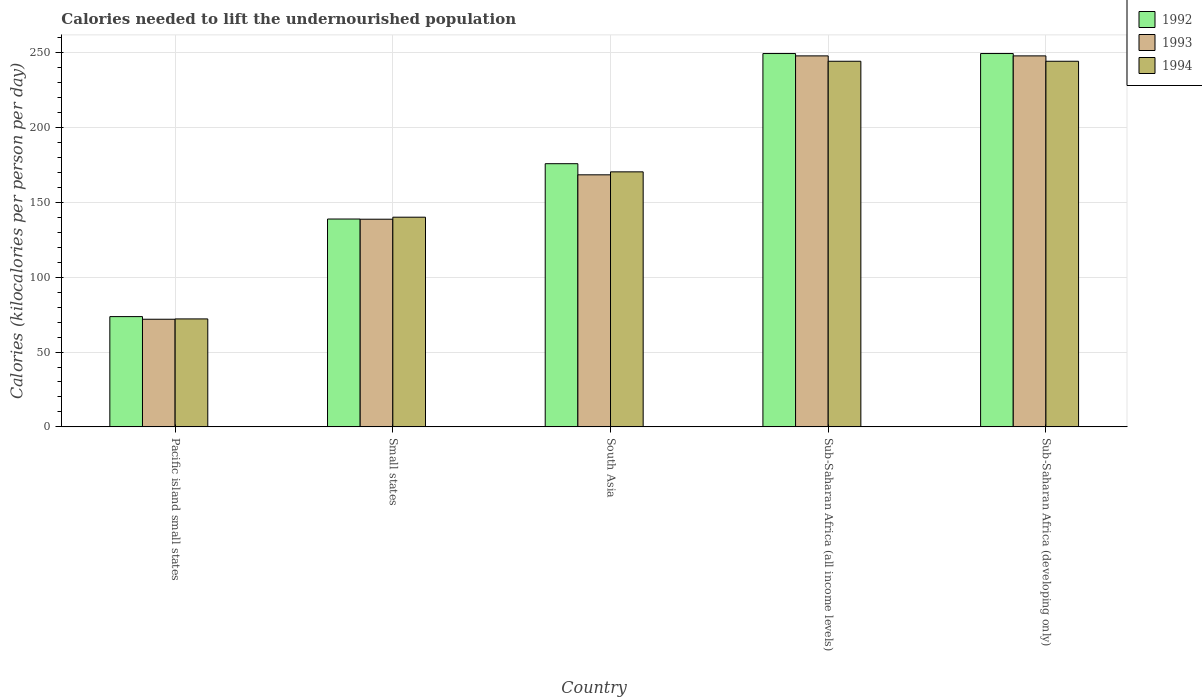How many groups of bars are there?
Make the answer very short. 5. Are the number of bars per tick equal to the number of legend labels?
Your answer should be very brief. Yes. How many bars are there on the 5th tick from the left?
Make the answer very short. 3. What is the label of the 1st group of bars from the left?
Your answer should be very brief. Pacific island small states. What is the total calories needed to lift the undernourished population in 1994 in Small states?
Keep it short and to the point. 140.1. Across all countries, what is the maximum total calories needed to lift the undernourished population in 1993?
Provide a short and direct response. 247.89. Across all countries, what is the minimum total calories needed to lift the undernourished population in 1992?
Give a very brief answer. 73.68. In which country was the total calories needed to lift the undernourished population in 1993 maximum?
Your response must be concise. Sub-Saharan Africa (all income levels). In which country was the total calories needed to lift the undernourished population in 1992 minimum?
Give a very brief answer. Pacific island small states. What is the total total calories needed to lift the undernourished population in 1992 in the graph?
Ensure brevity in your answer.  887.31. What is the difference between the total calories needed to lift the undernourished population in 1993 in Pacific island small states and that in Sub-Saharan Africa (all income levels)?
Offer a very short reply. -175.97. What is the difference between the total calories needed to lift the undernourished population in 1992 in Sub-Saharan Africa (developing only) and the total calories needed to lift the undernourished population in 1994 in Pacific island small states?
Make the answer very short. 177.32. What is the average total calories needed to lift the undernourished population in 1994 per country?
Your response must be concise. 174.25. What is the difference between the total calories needed to lift the undernourished population of/in 1992 and total calories needed to lift the undernourished population of/in 1994 in Small states?
Keep it short and to the point. -1.22. In how many countries, is the total calories needed to lift the undernourished population in 1992 greater than 250 kilocalories?
Provide a succinct answer. 0. What is the ratio of the total calories needed to lift the undernourished population in 1994 in Pacific island small states to that in Small states?
Your answer should be compact. 0.51. Is the total calories needed to lift the undernourished population in 1992 in Pacific island small states less than that in Sub-Saharan Africa (all income levels)?
Keep it short and to the point. Yes. What is the difference between the highest and the second highest total calories needed to lift the undernourished population in 1992?
Your answer should be very brief. 73.61. What is the difference between the highest and the lowest total calories needed to lift the undernourished population in 1992?
Your answer should be compact. 175.77. What does the 2nd bar from the left in Small states represents?
Your answer should be very brief. 1993. Is it the case that in every country, the sum of the total calories needed to lift the undernourished population in 1994 and total calories needed to lift the undernourished population in 1992 is greater than the total calories needed to lift the undernourished population in 1993?
Provide a succinct answer. Yes. How many bars are there?
Your answer should be compact. 15. Are all the bars in the graph horizontal?
Give a very brief answer. No. What is the difference between two consecutive major ticks on the Y-axis?
Provide a succinct answer. 50. Does the graph contain grids?
Your response must be concise. Yes. Where does the legend appear in the graph?
Ensure brevity in your answer.  Top right. How many legend labels are there?
Provide a short and direct response. 3. What is the title of the graph?
Your answer should be compact. Calories needed to lift the undernourished population. Does "1995" appear as one of the legend labels in the graph?
Provide a short and direct response. No. What is the label or title of the Y-axis?
Provide a succinct answer. Calories (kilocalories per person per day). What is the Calories (kilocalories per person per day) in 1992 in Pacific island small states?
Your response must be concise. 73.68. What is the Calories (kilocalories per person per day) in 1993 in Pacific island small states?
Your response must be concise. 71.92. What is the Calories (kilocalories per person per day) in 1994 in Pacific island small states?
Keep it short and to the point. 72.13. What is the Calories (kilocalories per person per day) in 1992 in Small states?
Provide a short and direct response. 138.88. What is the Calories (kilocalories per person per day) of 1993 in Small states?
Provide a succinct answer. 138.76. What is the Calories (kilocalories per person per day) in 1994 in Small states?
Keep it short and to the point. 140.1. What is the Calories (kilocalories per person per day) in 1992 in South Asia?
Offer a very short reply. 175.85. What is the Calories (kilocalories per person per day) of 1993 in South Asia?
Give a very brief answer. 168.41. What is the Calories (kilocalories per person per day) of 1994 in South Asia?
Provide a succinct answer. 170.4. What is the Calories (kilocalories per person per day) in 1992 in Sub-Saharan Africa (all income levels)?
Offer a very short reply. 249.45. What is the Calories (kilocalories per person per day) in 1993 in Sub-Saharan Africa (all income levels)?
Your answer should be compact. 247.89. What is the Calories (kilocalories per person per day) in 1994 in Sub-Saharan Africa (all income levels)?
Offer a terse response. 244.29. What is the Calories (kilocalories per person per day) in 1992 in Sub-Saharan Africa (developing only)?
Your answer should be very brief. 249.45. What is the Calories (kilocalories per person per day) of 1993 in Sub-Saharan Africa (developing only)?
Provide a short and direct response. 247.89. What is the Calories (kilocalories per person per day) in 1994 in Sub-Saharan Africa (developing only)?
Offer a very short reply. 244.29. Across all countries, what is the maximum Calories (kilocalories per person per day) of 1992?
Your answer should be very brief. 249.45. Across all countries, what is the maximum Calories (kilocalories per person per day) of 1993?
Provide a short and direct response. 247.89. Across all countries, what is the maximum Calories (kilocalories per person per day) in 1994?
Your answer should be very brief. 244.29. Across all countries, what is the minimum Calories (kilocalories per person per day) in 1992?
Your answer should be very brief. 73.68. Across all countries, what is the minimum Calories (kilocalories per person per day) in 1993?
Your answer should be compact. 71.92. Across all countries, what is the minimum Calories (kilocalories per person per day) in 1994?
Your answer should be compact. 72.13. What is the total Calories (kilocalories per person per day) of 1992 in the graph?
Your answer should be very brief. 887.31. What is the total Calories (kilocalories per person per day) of 1993 in the graph?
Your response must be concise. 874.86. What is the total Calories (kilocalories per person per day) of 1994 in the graph?
Offer a very short reply. 871.23. What is the difference between the Calories (kilocalories per person per day) in 1992 in Pacific island small states and that in Small states?
Provide a succinct answer. -65.2. What is the difference between the Calories (kilocalories per person per day) of 1993 in Pacific island small states and that in Small states?
Keep it short and to the point. -66.84. What is the difference between the Calories (kilocalories per person per day) of 1994 in Pacific island small states and that in Small states?
Your answer should be compact. -67.97. What is the difference between the Calories (kilocalories per person per day) of 1992 in Pacific island small states and that in South Asia?
Your response must be concise. -102.16. What is the difference between the Calories (kilocalories per person per day) of 1993 in Pacific island small states and that in South Asia?
Your answer should be compact. -96.49. What is the difference between the Calories (kilocalories per person per day) of 1994 in Pacific island small states and that in South Asia?
Keep it short and to the point. -98.27. What is the difference between the Calories (kilocalories per person per day) of 1992 in Pacific island small states and that in Sub-Saharan Africa (all income levels)?
Offer a terse response. -175.77. What is the difference between the Calories (kilocalories per person per day) in 1993 in Pacific island small states and that in Sub-Saharan Africa (all income levels)?
Ensure brevity in your answer.  -175.97. What is the difference between the Calories (kilocalories per person per day) in 1994 in Pacific island small states and that in Sub-Saharan Africa (all income levels)?
Keep it short and to the point. -172.16. What is the difference between the Calories (kilocalories per person per day) in 1992 in Pacific island small states and that in Sub-Saharan Africa (developing only)?
Offer a terse response. -175.77. What is the difference between the Calories (kilocalories per person per day) of 1993 in Pacific island small states and that in Sub-Saharan Africa (developing only)?
Keep it short and to the point. -175.97. What is the difference between the Calories (kilocalories per person per day) in 1994 in Pacific island small states and that in Sub-Saharan Africa (developing only)?
Your answer should be very brief. -172.16. What is the difference between the Calories (kilocalories per person per day) in 1992 in Small states and that in South Asia?
Make the answer very short. -36.96. What is the difference between the Calories (kilocalories per person per day) in 1993 in Small states and that in South Asia?
Ensure brevity in your answer.  -29.65. What is the difference between the Calories (kilocalories per person per day) in 1994 in Small states and that in South Asia?
Ensure brevity in your answer.  -30.3. What is the difference between the Calories (kilocalories per person per day) in 1992 in Small states and that in Sub-Saharan Africa (all income levels)?
Provide a short and direct response. -110.57. What is the difference between the Calories (kilocalories per person per day) of 1993 in Small states and that in Sub-Saharan Africa (all income levels)?
Give a very brief answer. -109.13. What is the difference between the Calories (kilocalories per person per day) in 1994 in Small states and that in Sub-Saharan Africa (all income levels)?
Your answer should be very brief. -104.19. What is the difference between the Calories (kilocalories per person per day) in 1992 in Small states and that in Sub-Saharan Africa (developing only)?
Offer a terse response. -110.57. What is the difference between the Calories (kilocalories per person per day) of 1993 in Small states and that in Sub-Saharan Africa (developing only)?
Your response must be concise. -109.13. What is the difference between the Calories (kilocalories per person per day) in 1994 in Small states and that in Sub-Saharan Africa (developing only)?
Your answer should be very brief. -104.19. What is the difference between the Calories (kilocalories per person per day) in 1992 in South Asia and that in Sub-Saharan Africa (all income levels)?
Keep it short and to the point. -73.61. What is the difference between the Calories (kilocalories per person per day) in 1993 in South Asia and that in Sub-Saharan Africa (all income levels)?
Provide a short and direct response. -79.48. What is the difference between the Calories (kilocalories per person per day) of 1994 in South Asia and that in Sub-Saharan Africa (all income levels)?
Give a very brief answer. -73.89. What is the difference between the Calories (kilocalories per person per day) in 1992 in South Asia and that in Sub-Saharan Africa (developing only)?
Your answer should be very brief. -73.61. What is the difference between the Calories (kilocalories per person per day) in 1993 in South Asia and that in Sub-Saharan Africa (developing only)?
Provide a short and direct response. -79.48. What is the difference between the Calories (kilocalories per person per day) of 1994 in South Asia and that in Sub-Saharan Africa (developing only)?
Your answer should be compact. -73.89. What is the difference between the Calories (kilocalories per person per day) of 1992 in Sub-Saharan Africa (all income levels) and that in Sub-Saharan Africa (developing only)?
Make the answer very short. 0. What is the difference between the Calories (kilocalories per person per day) in 1994 in Sub-Saharan Africa (all income levels) and that in Sub-Saharan Africa (developing only)?
Your answer should be very brief. 0. What is the difference between the Calories (kilocalories per person per day) of 1992 in Pacific island small states and the Calories (kilocalories per person per day) of 1993 in Small states?
Your response must be concise. -65.07. What is the difference between the Calories (kilocalories per person per day) of 1992 in Pacific island small states and the Calories (kilocalories per person per day) of 1994 in Small states?
Give a very brief answer. -66.42. What is the difference between the Calories (kilocalories per person per day) of 1993 in Pacific island small states and the Calories (kilocalories per person per day) of 1994 in Small states?
Offer a terse response. -68.18. What is the difference between the Calories (kilocalories per person per day) of 1992 in Pacific island small states and the Calories (kilocalories per person per day) of 1993 in South Asia?
Provide a succinct answer. -94.73. What is the difference between the Calories (kilocalories per person per day) in 1992 in Pacific island small states and the Calories (kilocalories per person per day) in 1994 in South Asia?
Ensure brevity in your answer.  -96.72. What is the difference between the Calories (kilocalories per person per day) of 1993 in Pacific island small states and the Calories (kilocalories per person per day) of 1994 in South Asia?
Make the answer very short. -98.48. What is the difference between the Calories (kilocalories per person per day) of 1992 in Pacific island small states and the Calories (kilocalories per person per day) of 1993 in Sub-Saharan Africa (all income levels)?
Offer a terse response. -174.2. What is the difference between the Calories (kilocalories per person per day) in 1992 in Pacific island small states and the Calories (kilocalories per person per day) in 1994 in Sub-Saharan Africa (all income levels)?
Your response must be concise. -170.61. What is the difference between the Calories (kilocalories per person per day) in 1993 in Pacific island small states and the Calories (kilocalories per person per day) in 1994 in Sub-Saharan Africa (all income levels)?
Offer a very short reply. -172.37. What is the difference between the Calories (kilocalories per person per day) of 1992 in Pacific island small states and the Calories (kilocalories per person per day) of 1993 in Sub-Saharan Africa (developing only)?
Keep it short and to the point. -174.2. What is the difference between the Calories (kilocalories per person per day) of 1992 in Pacific island small states and the Calories (kilocalories per person per day) of 1994 in Sub-Saharan Africa (developing only)?
Offer a very short reply. -170.61. What is the difference between the Calories (kilocalories per person per day) in 1993 in Pacific island small states and the Calories (kilocalories per person per day) in 1994 in Sub-Saharan Africa (developing only)?
Offer a very short reply. -172.37. What is the difference between the Calories (kilocalories per person per day) of 1992 in Small states and the Calories (kilocalories per person per day) of 1993 in South Asia?
Ensure brevity in your answer.  -29.53. What is the difference between the Calories (kilocalories per person per day) in 1992 in Small states and the Calories (kilocalories per person per day) in 1994 in South Asia?
Your answer should be compact. -31.52. What is the difference between the Calories (kilocalories per person per day) of 1993 in Small states and the Calories (kilocalories per person per day) of 1994 in South Asia?
Offer a very short reply. -31.64. What is the difference between the Calories (kilocalories per person per day) in 1992 in Small states and the Calories (kilocalories per person per day) in 1993 in Sub-Saharan Africa (all income levels)?
Your answer should be compact. -109.01. What is the difference between the Calories (kilocalories per person per day) in 1992 in Small states and the Calories (kilocalories per person per day) in 1994 in Sub-Saharan Africa (all income levels)?
Your response must be concise. -105.41. What is the difference between the Calories (kilocalories per person per day) of 1993 in Small states and the Calories (kilocalories per person per day) of 1994 in Sub-Saharan Africa (all income levels)?
Keep it short and to the point. -105.54. What is the difference between the Calories (kilocalories per person per day) in 1992 in Small states and the Calories (kilocalories per person per day) in 1993 in Sub-Saharan Africa (developing only)?
Give a very brief answer. -109.01. What is the difference between the Calories (kilocalories per person per day) in 1992 in Small states and the Calories (kilocalories per person per day) in 1994 in Sub-Saharan Africa (developing only)?
Give a very brief answer. -105.41. What is the difference between the Calories (kilocalories per person per day) in 1993 in Small states and the Calories (kilocalories per person per day) in 1994 in Sub-Saharan Africa (developing only)?
Provide a succinct answer. -105.54. What is the difference between the Calories (kilocalories per person per day) in 1992 in South Asia and the Calories (kilocalories per person per day) in 1993 in Sub-Saharan Africa (all income levels)?
Provide a succinct answer. -72.04. What is the difference between the Calories (kilocalories per person per day) in 1992 in South Asia and the Calories (kilocalories per person per day) in 1994 in Sub-Saharan Africa (all income levels)?
Give a very brief answer. -68.45. What is the difference between the Calories (kilocalories per person per day) of 1993 in South Asia and the Calories (kilocalories per person per day) of 1994 in Sub-Saharan Africa (all income levels)?
Provide a succinct answer. -75.88. What is the difference between the Calories (kilocalories per person per day) of 1992 in South Asia and the Calories (kilocalories per person per day) of 1993 in Sub-Saharan Africa (developing only)?
Give a very brief answer. -72.04. What is the difference between the Calories (kilocalories per person per day) in 1992 in South Asia and the Calories (kilocalories per person per day) in 1994 in Sub-Saharan Africa (developing only)?
Offer a very short reply. -68.45. What is the difference between the Calories (kilocalories per person per day) of 1993 in South Asia and the Calories (kilocalories per person per day) of 1994 in Sub-Saharan Africa (developing only)?
Offer a terse response. -75.88. What is the difference between the Calories (kilocalories per person per day) in 1992 in Sub-Saharan Africa (all income levels) and the Calories (kilocalories per person per day) in 1993 in Sub-Saharan Africa (developing only)?
Provide a short and direct response. 1.56. What is the difference between the Calories (kilocalories per person per day) in 1992 in Sub-Saharan Africa (all income levels) and the Calories (kilocalories per person per day) in 1994 in Sub-Saharan Africa (developing only)?
Make the answer very short. 5.16. What is the difference between the Calories (kilocalories per person per day) in 1993 in Sub-Saharan Africa (all income levels) and the Calories (kilocalories per person per day) in 1994 in Sub-Saharan Africa (developing only)?
Give a very brief answer. 3.59. What is the average Calories (kilocalories per person per day) of 1992 per country?
Your answer should be very brief. 177.46. What is the average Calories (kilocalories per person per day) in 1993 per country?
Your answer should be compact. 174.97. What is the average Calories (kilocalories per person per day) of 1994 per country?
Your answer should be compact. 174.25. What is the difference between the Calories (kilocalories per person per day) in 1992 and Calories (kilocalories per person per day) in 1993 in Pacific island small states?
Your answer should be compact. 1.76. What is the difference between the Calories (kilocalories per person per day) in 1992 and Calories (kilocalories per person per day) in 1994 in Pacific island small states?
Give a very brief answer. 1.55. What is the difference between the Calories (kilocalories per person per day) of 1993 and Calories (kilocalories per person per day) of 1994 in Pacific island small states?
Ensure brevity in your answer.  -0.21. What is the difference between the Calories (kilocalories per person per day) of 1992 and Calories (kilocalories per person per day) of 1993 in Small states?
Offer a terse response. 0.12. What is the difference between the Calories (kilocalories per person per day) in 1992 and Calories (kilocalories per person per day) in 1994 in Small states?
Your answer should be compact. -1.22. What is the difference between the Calories (kilocalories per person per day) of 1993 and Calories (kilocalories per person per day) of 1994 in Small states?
Your response must be concise. -1.34. What is the difference between the Calories (kilocalories per person per day) of 1992 and Calories (kilocalories per person per day) of 1993 in South Asia?
Ensure brevity in your answer.  7.44. What is the difference between the Calories (kilocalories per person per day) in 1992 and Calories (kilocalories per person per day) in 1994 in South Asia?
Your answer should be very brief. 5.44. What is the difference between the Calories (kilocalories per person per day) of 1993 and Calories (kilocalories per person per day) of 1994 in South Asia?
Make the answer very short. -1.99. What is the difference between the Calories (kilocalories per person per day) in 1992 and Calories (kilocalories per person per day) in 1993 in Sub-Saharan Africa (all income levels)?
Make the answer very short. 1.56. What is the difference between the Calories (kilocalories per person per day) in 1992 and Calories (kilocalories per person per day) in 1994 in Sub-Saharan Africa (all income levels)?
Your answer should be very brief. 5.16. What is the difference between the Calories (kilocalories per person per day) of 1993 and Calories (kilocalories per person per day) of 1994 in Sub-Saharan Africa (all income levels)?
Your answer should be compact. 3.59. What is the difference between the Calories (kilocalories per person per day) in 1992 and Calories (kilocalories per person per day) in 1993 in Sub-Saharan Africa (developing only)?
Your answer should be very brief. 1.56. What is the difference between the Calories (kilocalories per person per day) of 1992 and Calories (kilocalories per person per day) of 1994 in Sub-Saharan Africa (developing only)?
Your answer should be very brief. 5.16. What is the difference between the Calories (kilocalories per person per day) in 1993 and Calories (kilocalories per person per day) in 1994 in Sub-Saharan Africa (developing only)?
Your response must be concise. 3.59. What is the ratio of the Calories (kilocalories per person per day) of 1992 in Pacific island small states to that in Small states?
Make the answer very short. 0.53. What is the ratio of the Calories (kilocalories per person per day) in 1993 in Pacific island small states to that in Small states?
Give a very brief answer. 0.52. What is the ratio of the Calories (kilocalories per person per day) in 1994 in Pacific island small states to that in Small states?
Make the answer very short. 0.51. What is the ratio of the Calories (kilocalories per person per day) in 1992 in Pacific island small states to that in South Asia?
Offer a very short reply. 0.42. What is the ratio of the Calories (kilocalories per person per day) in 1993 in Pacific island small states to that in South Asia?
Your answer should be compact. 0.43. What is the ratio of the Calories (kilocalories per person per day) in 1994 in Pacific island small states to that in South Asia?
Ensure brevity in your answer.  0.42. What is the ratio of the Calories (kilocalories per person per day) of 1992 in Pacific island small states to that in Sub-Saharan Africa (all income levels)?
Your answer should be compact. 0.3. What is the ratio of the Calories (kilocalories per person per day) in 1993 in Pacific island small states to that in Sub-Saharan Africa (all income levels)?
Ensure brevity in your answer.  0.29. What is the ratio of the Calories (kilocalories per person per day) in 1994 in Pacific island small states to that in Sub-Saharan Africa (all income levels)?
Your answer should be compact. 0.3. What is the ratio of the Calories (kilocalories per person per day) in 1992 in Pacific island small states to that in Sub-Saharan Africa (developing only)?
Give a very brief answer. 0.3. What is the ratio of the Calories (kilocalories per person per day) in 1993 in Pacific island small states to that in Sub-Saharan Africa (developing only)?
Offer a very short reply. 0.29. What is the ratio of the Calories (kilocalories per person per day) in 1994 in Pacific island small states to that in Sub-Saharan Africa (developing only)?
Provide a short and direct response. 0.3. What is the ratio of the Calories (kilocalories per person per day) in 1992 in Small states to that in South Asia?
Make the answer very short. 0.79. What is the ratio of the Calories (kilocalories per person per day) of 1993 in Small states to that in South Asia?
Ensure brevity in your answer.  0.82. What is the ratio of the Calories (kilocalories per person per day) of 1994 in Small states to that in South Asia?
Ensure brevity in your answer.  0.82. What is the ratio of the Calories (kilocalories per person per day) in 1992 in Small states to that in Sub-Saharan Africa (all income levels)?
Give a very brief answer. 0.56. What is the ratio of the Calories (kilocalories per person per day) of 1993 in Small states to that in Sub-Saharan Africa (all income levels)?
Your response must be concise. 0.56. What is the ratio of the Calories (kilocalories per person per day) of 1994 in Small states to that in Sub-Saharan Africa (all income levels)?
Provide a succinct answer. 0.57. What is the ratio of the Calories (kilocalories per person per day) in 1992 in Small states to that in Sub-Saharan Africa (developing only)?
Ensure brevity in your answer.  0.56. What is the ratio of the Calories (kilocalories per person per day) of 1993 in Small states to that in Sub-Saharan Africa (developing only)?
Make the answer very short. 0.56. What is the ratio of the Calories (kilocalories per person per day) in 1994 in Small states to that in Sub-Saharan Africa (developing only)?
Provide a short and direct response. 0.57. What is the ratio of the Calories (kilocalories per person per day) of 1992 in South Asia to that in Sub-Saharan Africa (all income levels)?
Provide a succinct answer. 0.7. What is the ratio of the Calories (kilocalories per person per day) of 1993 in South Asia to that in Sub-Saharan Africa (all income levels)?
Give a very brief answer. 0.68. What is the ratio of the Calories (kilocalories per person per day) in 1994 in South Asia to that in Sub-Saharan Africa (all income levels)?
Offer a terse response. 0.7. What is the ratio of the Calories (kilocalories per person per day) of 1992 in South Asia to that in Sub-Saharan Africa (developing only)?
Your answer should be compact. 0.7. What is the ratio of the Calories (kilocalories per person per day) of 1993 in South Asia to that in Sub-Saharan Africa (developing only)?
Provide a succinct answer. 0.68. What is the ratio of the Calories (kilocalories per person per day) in 1994 in South Asia to that in Sub-Saharan Africa (developing only)?
Give a very brief answer. 0.7. What is the ratio of the Calories (kilocalories per person per day) in 1992 in Sub-Saharan Africa (all income levels) to that in Sub-Saharan Africa (developing only)?
Make the answer very short. 1. What is the ratio of the Calories (kilocalories per person per day) in 1994 in Sub-Saharan Africa (all income levels) to that in Sub-Saharan Africa (developing only)?
Ensure brevity in your answer.  1. What is the difference between the highest and the second highest Calories (kilocalories per person per day) in 1993?
Give a very brief answer. 0. What is the difference between the highest and the second highest Calories (kilocalories per person per day) of 1994?
Provide a succinct answer. 0. What is the difference between the highest and the lowest Calories (kilocalories per person per day) of 1992?
Your response must be concise. 175.77. What is the difference between the highest and the lowest Calories (kilocalories per person per day) in 1993?
Offer a terse response. 175.97. What is the difference between the highest and the lowest Calories (kilocalories per person per day) of 1994?
Offer a very short reply. 172.16. 